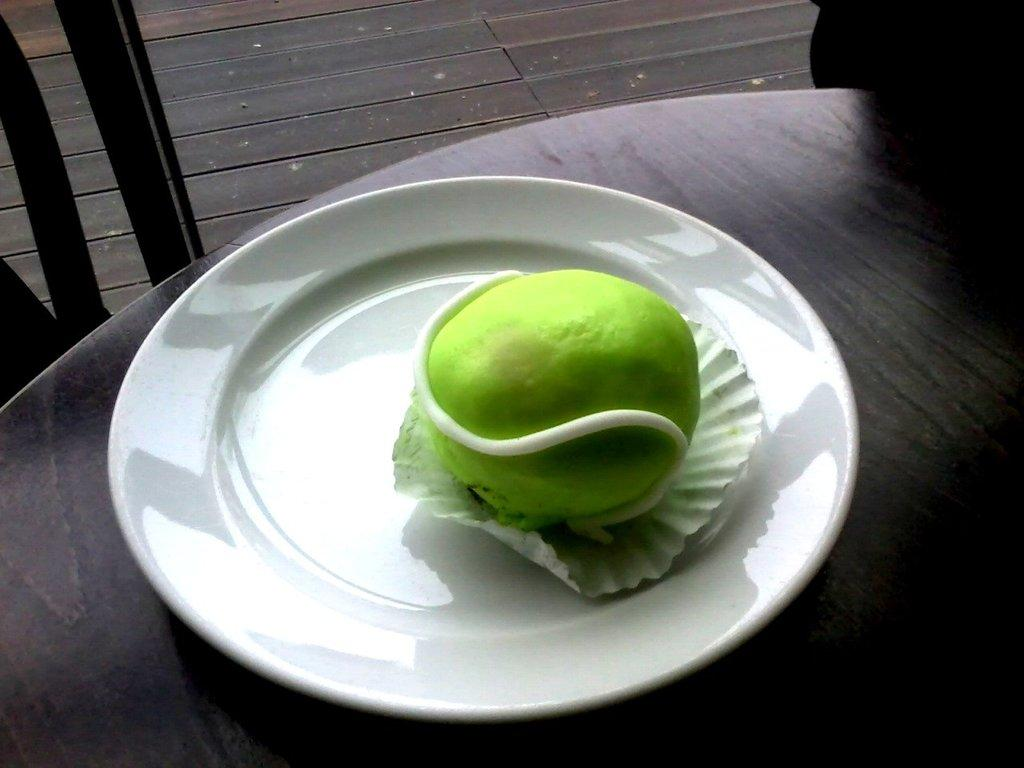What is on the platter that is visible in the image? There is a food item on a platter in the image. Where is the platter located? The platter is on a table in the image. What else can be seen in the image besides the platter? Chairs are visible at the top of the image, and the floor is visible in the image. What type of print can be seen on the donkey's back in the image? There is no donkey present in the image, so it is not possible to answer that question. 